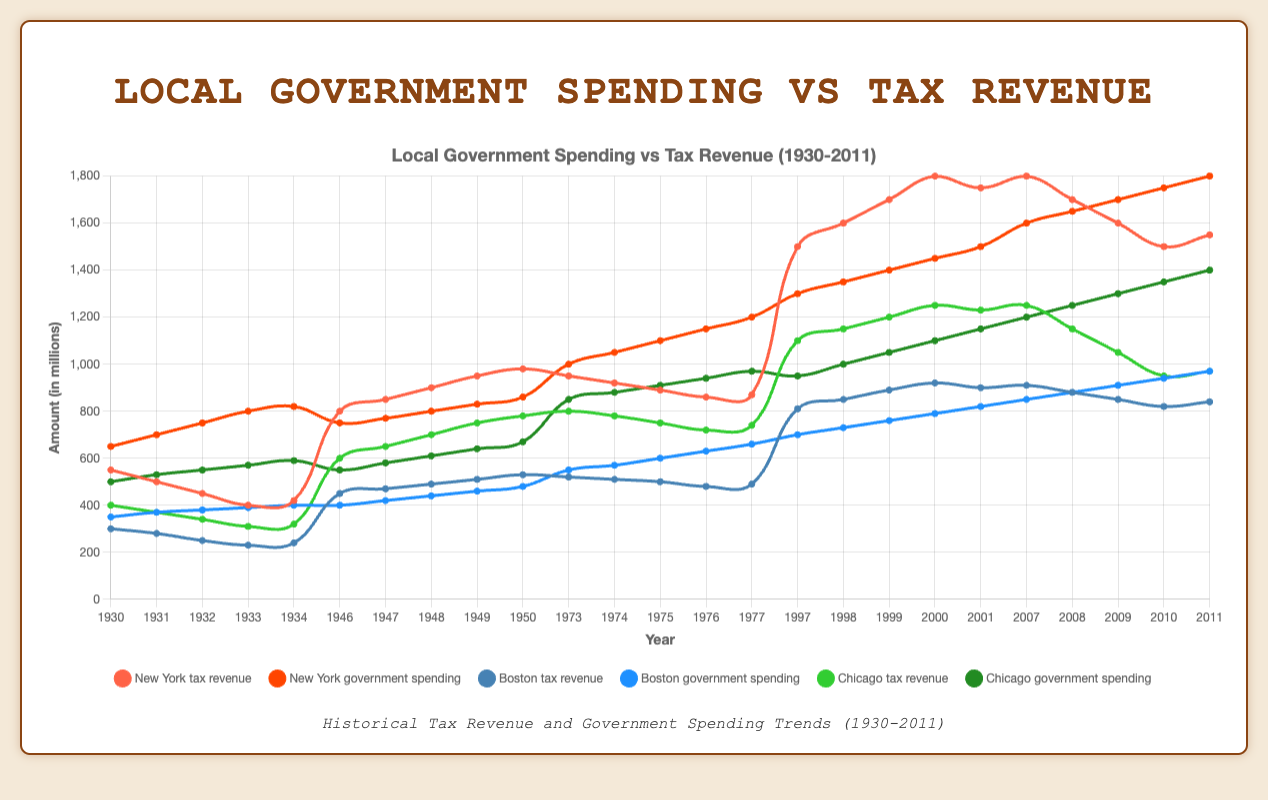What's the average tax revenue for Chicago during the Dot-com Bubble period? To find the average tax revenue for Chicago during the Dot-com Bubble period, sum the revenue values for each year: 1100 + 1150 + 1200 + 1250 + 1230 = 5930. Then, divide by the number of years (5): 5930 / 5 = 1186
Answer: 1186 How does government spending in Boston in 1932 compare to 1934? Looking at the government spending data for Boston in 1932 and 1934: 1932 = 380 and 1934 = 400. The difference is 400 - 380 = 20 million. Government spending in Boston increased by 20 million from 1932 to 1934
Answer: Increased by 20 million Which city had the highest tax revenue in the year 1999? For the year 1999, we compare the tax revenue across the three cities: New York (1700), Boston (890), and Chicago (1200). New York had the highest tax revenue at 1700 million
Answer: New York Did Boston's tax revenue grow or shrink during the Great Depression from 1930 to 1934? Examining Boston's tax revenue during the Great Depression: 1930 (300), 1934 (240). The tax revenue decreased by 60 million, indicating a shrinkage
Answer: Shrink By how much did New York's government spending exceed tax revenue during the 1970s Stagflation in 1977? From 1973 to 1977, New York's government spending was 1200, and the tax revenue was 870 in 1977. The difference is 1200 - 870 = 330 million
Answer: 330 million Compare Chicago's government spending in 2009 to its tax revenue in the same year. Chicago's government spending in 2009 was 1300, and tax revenue was 1050. The difference is 1300 - 1050 = 250 million more in spending
Answer: 250 million more in spending What's the overall trend in New York's tax revenue during the Great Recession period? For the Great Recession period (2007-2011), NY's tax revenue started at 1800 in 2007 and ended at 1550 in 2011, showing a decreasing trend
Answer: Decreasing trend What was the percentage decrease in Chicago's tax revenue from 2008 to 2009 during the Great Recession? The tax revenue for Chicago in 2008 was 1150, and in 2009 it dropped to 1050. The percentage decrease is ((1150 - 1050) / 1150) * 100 = (100 / 1150) * 100 ≈ 8.7%
Answer: 8.7% Which period saw the highest government spending for New York? Comparing peak values across periods: Great Depression (820), Post-WWII Boom (860), Stagflation (1200), Dot-com Bubble (1500), Great Recession (1800), the Great Recession period had the highest spending at 1800 million
Answer: Great Recession 